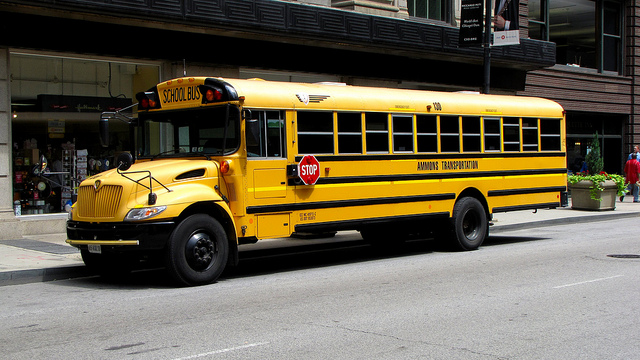Extract all visible text content from this image. STOP SCHOOL BUS 